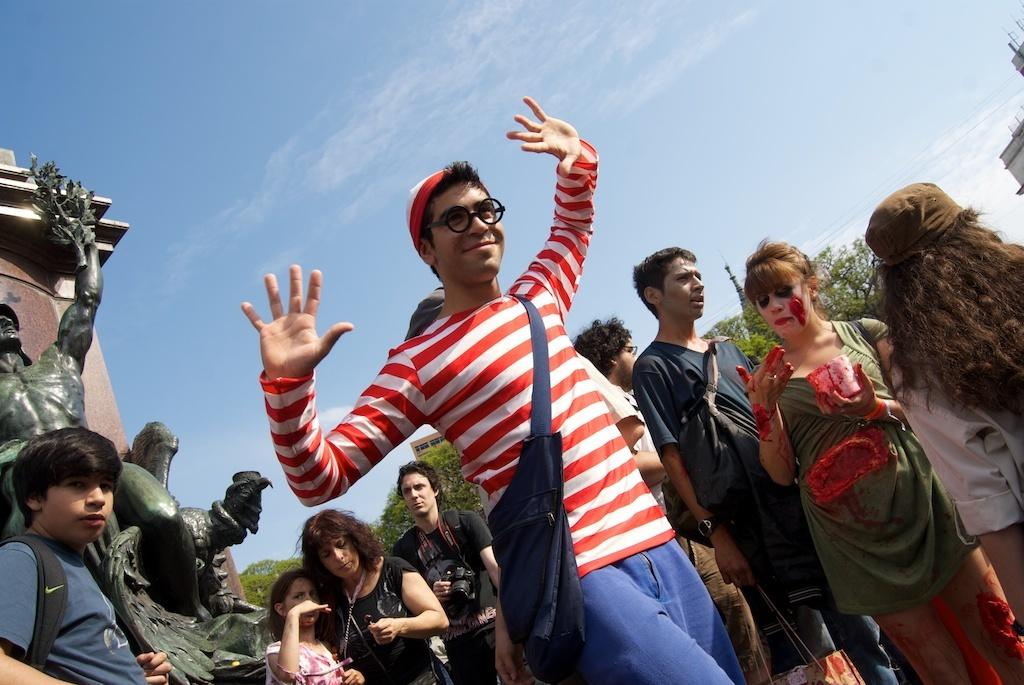How many people are in the group that is visible in the image? There is a group of people in the image, but the exact number is not specified. What are some people in the group carrying? Some people in the group are carrying bags. What can be seen in the background of the image? In the background of the image, there are statues, trees, buildings, and the sky. Can you describe the setting of the image? The image appears to be set in an outdoor area with statues, trees, and buildings in the background. What type of account is being discussed by the people in the image? There is no indication in the image that the people are discussing any type of account. Can you describe the shape of the circle in the image? There is no circle present in the image. 